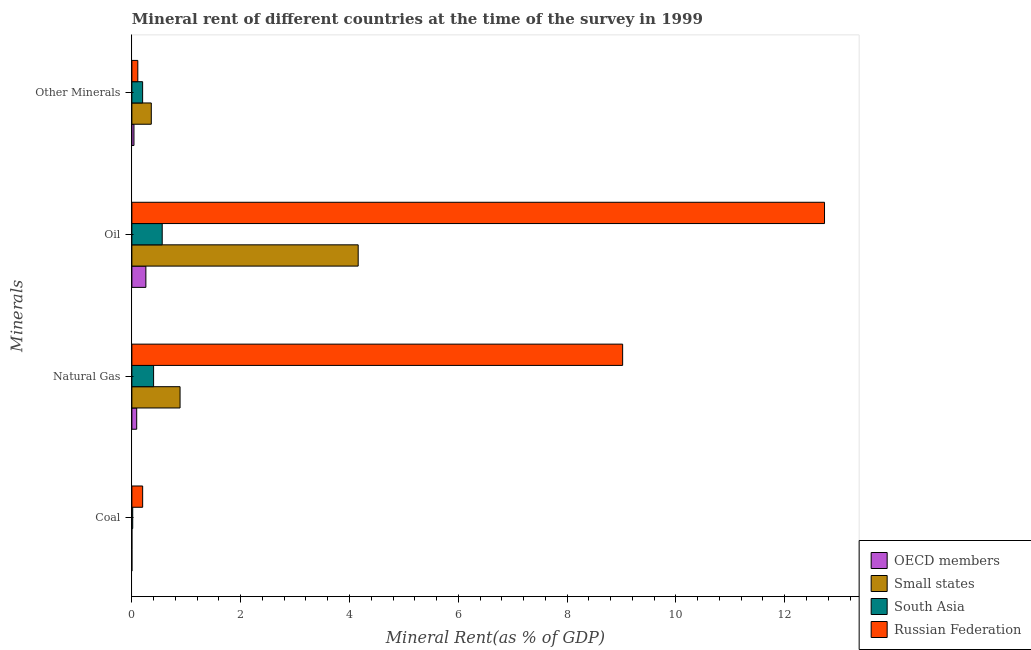How many different coloured bars are there?
Offer a very short reply. 4. How many groups of bars are there?
Offer a very short reply. 4. Are the number of bars per tick equal to the number of legend labels?
Your answer should be very brief. Yes. What is the label of the 4th group of bars from the top?
Offer a very short reply. Coal. What is the oil rent in Small states?
Provide a succinct answer. 4.16. Across all countries, what is the maximum  rent of other minerals?
Offer a very short reply. 0.36. Across all countries, what is the minimum  rent of other minerals?
Your answer should be very brief. 0.04. In which country was the  rent of other minerals maximum?
Ensure brevity in your answer.  Small states. What is the total natural gas rent in the graph?
Keep it short and to the point. 10.39. What is the difference between the natural gas rent in Russian Federation and that in OECD members?
Your response must be concise. 8.93. What is the difference between the oil rent in South Asia and the natural gas rent in OECD members?
Provide a short and direct response. 0.47. What is the average natural gas rent per country?
Offer a terse response. 2.6. What is the difference between the  rent of other minerals and coal rent in Small states?
Keep it short and to the point. 0.36. What is the ratio of the oil rent in Russian Federation to that in South Asia?
Your answer should be very brief. 22.82. Is the natural gas rent in Small states less than that in Russian Federation?
Keep it short and to the point. Yes. What is the difference between the highest and the second highest natural gas rent?
Give a very brief answer. 8.13. What is the difference between the highest and the lowest  rent of other minerals?
Ensure brevity in your answer.  0.32. In how many countries, is the coal rent greater than the average coal rent taken over all countries?
Make the answer very short. 1. What does the 2nd bar from the bottom in Oil represents?
Provide a short and direct response. Small states. Is it the case that in every country, the sum of the coal rent and natural gas rent is greater than the oil rent?
Keep it short and to the point. No. Are all the bars in the graph horizontal?
Your answer should be very brief. Yes. Are the values on the major ticks of X-axis written in scientific E-notation?
Give a very brief answer. No. Where does the legend appear in the graph?
Your answer should be compact. Bottom right. What is the title of the graph?
Your answer should be very brief. Mineral rent of different countries at the time of the survey in 1999. Does "Palau" appear as one of the legend labels in the graph?
Offer a terse response. No. What is the label or title of the X-axis?
Ensure brevity in your answer.  Mineral Rent(as % of GDP). What is the label or title of the Y-axis?
Ensure brevity in your answer.  Minerals. What is the Mineral Rent(as % of GDP) of OECD members in Coal?
Your response must be concise. 7.35477210860239e-5. What is the Mineral Rent(as % of GDP) in Small states in Coal?
Give a very brief answer. 3.53055328740538e-5. What is the Mineral Rent(as % of GDP) of South Asia in Coal?
Provide a succinct answer. 0.02. What is the Mineral Rent(as % of GDP) in Russian Federation in Coal?
Ensure brevity in your answer.  0.2. What is the Mineral Rent(as % of GDP) in OECD members in Natural Gas?
Offer a terse response. 0.09. What is the Mineral Rent(as % of GDP) in Small states in Natural Gas?
Your response must be concise. 0.89. What is the Mineral Rent(as % of GDP) of South Asia in Natural Gas?
Offer a terse response. 0.4. What is the Mineral Rent(as % of GDP) of Russian Federation in Natural Gas?
Your response must be concise. 9.02. What is the Mineral Rent(as % of GDP) in OECD members in Oil?
Keep it short and to the point. 0.26. What is the Mineral Rent(as % of GDP) of Small states in Oil?
Make the answer very short. 4.16. What is the Mineral Rent(as % of GDP) of South Asia in Oil?
Keep it short and to the point. 0.56. What is the Mineral Rent(as % of GDP) of Russian Federation in Oil?
Your answer should be very brief. 12.73. What is the Mineral Rent(as % of GDP) of OECD members in Other Minerals?
Make the answer very short. 0.04. What is the Mineral Rent(as % of GDP) of Small states in Other Minerals?
Give a very brief answer. 0.36. What is the Mineral Rent(as % of GDP) in South Asia in Other Minerals?
Your response must be concise. 0.2. What is the Mineral Rent(as % of GDP) in Russian Federation in Other Minerals?
Provide a short and direct response. 0.11. Across all Minerals, what is the maximum Mineral Rent(as % of GDP) in OECD members?
Provide a succinct answer. 0.26. Across all Minerals, what is the maximum Mineral Rent(as % of GDP) in Small states?
Ensure brevity in your answer.  4.16. Across all Minerals, what is the maximum Mineral Rent(as % of GDP) of South Asia?
Offer a terse response. 0.56. Across all Minerals, what is the maximum Mineral Rent(as % of GDP) of Russian Federation?
Your answer should be compact. 12.73. Across all Minerals, what is the minimum Mineral Rent(as % of GDP) of OECD members?
Make the answer very short. 7.35477210860239e-5. Across all Minerals, what is the minimum Mineral Rent(as % of GDP) of Small states?
Offer a terse response. 3.53055328740538e-5. Across all Minerals, what is the minimum Mineral Rent(as % of GDP) in South Asia?
Offer a very short reply. 0.02. Across all Minerals, what is the minimum Mineral Rent(as % of GDP) in Russian Federation?
Provide a succinct answer. 0.11. What is the total Mineral Rent(as % of GDP) of OECD members in the graph?
Give a very brief answer. 0.38. What is the total Mineral Rent(as % of GDP) in Small states in the graph?
Offer a very short reply. 5.4. What is the total Mineral Rent(as % of GDP) in South Asia in the graph?
Give a very brief answer. 1.17. What is the total Mineral Rent(as % of GDP) in Russian Federation in the graph?
Provide a short and direct response. 22.06. What is the difference between the Mineral Rent(as % of GDP) in OECD members in Coal and that in Natural Gas?
Make the answer very short. -0.09. What is the difference between the Mineral Rent(as % of GDP) in Small states in Coal and that in Natural Gas?
Offer a very short reply. -0.89. What is the difference between the Mineral Rent(as % of GDP) of South Asia in Coal and that in Natural Gas?
Your answer should be compact. -0.38. What is the difference between the Mineral Rent(as % of GDP) of Russian Federation in Coal and that in Natural Gas?
Ensure brevity in your answer.  -8.82. What is the difference between the Mineral Rent(as % of GDP) of OECD members in Coal and that in Oil?
Provide a short and direct response. -0.26. What is the difference between the Mineral Rent(as % of GDP) of Small states in Coal and that in Oil?
Make the answer very short. -4.16. What is the difference between the Mineral Rent(as % of GDP) in South Asia in Coal and that in Oil?
Ensure brevity in your answer.  -0.54. What is the difference between the Mineral Rent(as % of GDP) in Russian Federation in Coal and that in Oil?
Ensure brevity in your answer.  -12.53. What is the difference between the Mineral Rent(as % of GDP) in OECD members in Coal and that in Other Minerals?
Ensure brevity in your answer.  -0.04. What is the difference between the Mineral Rent(as % of GDP) in Small states in Coal and that in Other Minerals?
Provide a succinct answer. -0.36. What is the difference between the Mineral Rent(as % of GDP) in South Asia in Coal and that in Other Minerals?
Your answer should be compact. -0.18. What is the difference between the Mineral Rent(as % of GDP) of Russian Federation in Coal and that in Other Minerals?
Provide a succinct answer. 0.09. What is the difference between the Mineral Rent(as % of GDP) in OECD members in Natural Gas and that in Oil?
Offer a terse response. -0.17. What is the difference between the Mineral Rent(as % of GDP) in Small states in Natural Gas and that in Oil?
Make the answer very short. -3.27. What is the difference between the Mineral Rent(as % of GDP) in South Asia in Natural Gas and that in Oil?
Offer a terse response. -0.16. What is the difference between the Mineral Rent(as % of GDP) in Russian Federation in Natural Gas and that in Oil?
Your response must be concise. -3.71. What is the difference between the Mineral Rent(as % of GDP) of OECD members in Natural Gas and that in Other Minerals?
Make the answer very short. 0.05. What is the difference between the Mineral Rent(as % of GDP) in Small states in Natural Gas and that in Other Minerals?
Offer a very short reply. 0.53. What is the difference between the Mineral Rent(as % of GDP) of South Asia in Natural Gas and that in Other Minerals?
Provide a short and direct response. 0.2. What is the difference between the Mineral Rent(as % of GDP) of Russian Federation in Natural Gas and that in Other Minerals?
Keep it short and to the point. 8.91. What is the difference between the Mineral Rent(as % of GDP) of OECD members in Oil and that in Other Minerals?
Offer a very short reply. 0.22. What is the difference between the Mineral Rent(as % of GDP) of Small states in Oil and that in Other Minerals?
Your response must be concise. 3.8. What is the difference between the Mineral Rent(as % of GDP) in South Asia in Oil and that in Other Minerals?
Provide a short and direct response. 0.36. What is the difference between the Mineral Rent(as % of GDP) in Russian Federation in Oil and that in Other Minerals?
Offer a terse response. 12.62. What is the difference between the Mineral Rent(as % of GDP) in OECD members in Coal and the Mineral Rent(as % of GDP) in Small states in Natural Gas?
Offer a terse response. -0.89. What is the difference between the Mineral Rent(as % of GDP) of OECD members in Coal and the Mineral Rent(as % of GDP) of South Asia in Natural Gas?
Your response must be concise. -0.4. What is the difference between the Mineral Rent(as % of GDP) of OECD members in Coal and the Mineral Rent(as % of GDP) of Russian Federation in Natural Gas?
Offer a very short reply. -9.02. What is the difference between the Mineral Rent(as % of GDP) of Small states in Coal and the Mineral Rent(as % of GDP) of South Asia in Natural Gas?
Make the answer very short. -0.4. What is the difference between the Mineral Rent(as % of GDP) of Small states in Coal and the Mineral Rent(as % of GDP) of Russian Federation in Natural Gas?
Give a very brief answer. -9.02. What is the difference between the Mineral Rent(as % of GDP) in South Asia in Coal and the Mineral Rent(as % of GDP) in Russian Federation in Natural Gas?
Offer a terse response. -9. What is the difference between the Mineral Rent(as % of GDP) of OECD members in Coal and the Mineral Rent(as % of GDP) of Small states in Oil?
Give a very brief answer. -4.16. What is the difference between the Mineral Rent(as % of GDP) in OECD members in Coal and the Mineral Rent(as % of GDP) in South Asia in Oil?
Keep it short and to the point. -0.56. What is the difference between the Mineral Rent(as % of GDP) in OECD members in Coal and the Mineral Rent(as % of GDP) in Russian Federation in Oil?
Make the answer very short. -12.73. What is the difference between the Mineral Rent(as % of GDP) of Small states in Coal and the Mineral Rent(as % of GDP) of South Asia in Oil?
Make the answer very short. -0.56. What is the difference between the Mineral Rent(as % of GDP) of Small states in Coal and the Mineral Rent(as % of GDP) of Russian Federation in Oil?
Provide a short and direct response. -12.73. What is the difference between the Mineral Rent(as % of GDP) in South Asia in Coal and the Mineral Rent(as % of GDP) in Russian Federation in Oil?
Offer a very short reply. -12.72. What is the difference between the Mineral Rent(as % of GDP) in OECD members in Coal and the Mineral Rent(as % of GDP) in Small states in Other Minerals?
Give a very brief answer. -0.36. What is the difference between the Mineral Rent(as % of GDP) in OECD members in Coal and the Mineral Rent(as % of GDP) in South Asia in Other Minerals?
Your response must be concise. -0.2. What is the difference between the Mineral Rent(as % of GDP) in OECD members in Coal and the Mineral Rent(as % of GDP) in Russian Federation in Other Minerals?
Offer a very short reply. -0.11. What is the difference between the Mineral Rent(as % of GDP) in Small states in Coal and the Mineral Rent(as % of GDP) in South Asia in Other Minerals?
Ensure brevity in your answer.  -0.2. What is the difference between the Mineral Rent(as % of GDP) in Small states in Coal and the Mineral Rent(as % of GDP) in Russian Federation in Other Minerals?
Your answer should be very brief. -0.11. What is the difference between the Mineral Rent(as % of GDP) of South Asia in Coal and the Mineral Rent(as % of GDP) of Russian Federation in Other Minerals?
Your answer should be very brief. -0.09. What is the difference between the Mineral Rent(as % of GDP) of OECD members in Natural Gas and the Mineral Rent(as % of GDP) of Small states in Oil?
Provide a succinct answer. -4.07. What is the difference between the Mineral Rent(as % of GDP) of OECD members in Natural Gas and the Mineral Rent(as % of GDP) of South Asia in Oil?
Keep it short and to the point. -0.47. What is the difference between the Mineral Rent(as % of GDP) in OECD members in Natural Gas and the Mineral Rent(as % of GDP) in Russian Federation in Oil?
Ensure brevity in your answer.  -12.64. What is the difference between the Mineral Rent(as % of GDP) of Small states in Natural Gas and the Mineral Rent(as % of GDP) of South Asia in Oil?
Your answer should be compact. 0.33. What is the difference between the Mineral Rent(as % of GDP) of Small states in Natural Gas and the Mineral Rent(as % of GDP) of Russian Federation in Oil?
Give a very brief answer. -11.85. What is the difference between the Mineral Rent(as % of GDP) in South Asia in Natural Gas and the Mineral Rent(as % of GDP) in Russian Federation in Oil?
Your answer should be compact. -12.33. What is the difference between the Mineral Rent(as % of GDP) in OECD members in Natural Gas and the Mineral Rent(as % of GDP) in Small states in Other Minerals?
Offer a very short reply. -0.27. What is the difference between the Mineral Rent(as % of GDP) of OECD members in Natural Gas and the Mineral Rent(as % of GDP) of South Asia in Other Minerals?
Your response must be concise. -0.11. What is the difference between the Mineral Rent(as % of GDP) in OECD members in Natural Gas and the Mineral Rent(as % of GDP) in Russian Federation in Other Minerals?
Offer a very short reply. -0.02. What is the difference between the Mineral Rent(as % of GDP) in Small states in Natural Gas and the Mineral Rent(as % of GDP) in South Asia in Other Minerals?
Ensure brevity in your answer.  0.69. What is the difference between the Mineral Rent(as % of GDP) of Small states in Natural Gas and the Mineral Rent(as % of GDP) of Russian Federation in Other Minerals?
Your answer should be compact. 0.78. What is the difference between the Mineral Rent(as % of GDP) of South Asia in Natural Gas and the Mineral Rent(as % of GDP) of Russian Federation in Other Minerals?
Your answer should be very brief. 0.29. What is the difference between the Mineral Rent(as % of GDP) of OECD members in Oil and the Mineral Rent(as % of GDP) of Small states in Other Minerals?
Make the answer very short. -0.1. What is the difference between the Mineral Rent(as % of GDP) of OECD members in Oil and the Mineral Rent(as % of GDP) of South Asia in Other Minerals?
Your answer should be compact. 0.06. What is the difference between the Mineral Rent(as % of GDP) in OECD members in Oil and the Mineral Rent(as % of GDP) in Russian Federation in Other Minerals?
Your answer should be compact. 0.15. What is the difference between the Mineral Rent(as % of GDP) in Small states in Oil and the Mineral Rent(as % of GDP) in South Asia in Other Minerals?
Offer a very short reply. 3.96. What is the difference between the Mineral Rent(as % of GDP) in Small states in Oil and the Mineral Rent(as % of GDP) in Russian Federation in Other Minerals?
Make the answer very short. 4.05. What is the difference between the Mineral Rent(as % of GDP) in South Asia in Oil and the Mineral Rent(as % of GDP) in Russian Federation in Other Minerals?
Offer a terse response. 0.45. What is the average Mineral Rent(as % of GDP) in OECD members per Minerals?
Provide a short and direct response. 0.1. What is the average Mineral Rent(as % of GDP) in Small states per Minerals?
Ensure brevity in your answer.  1.35. What is the average Mineral Rent(as % of GDP) in South Asia per Minerals?
Ensure brevity in your answer.  0.29. What is the average Mineral Rent(as % of GDP) in Russian Federation per Minerals?
Ensure brevity in your answer.  5.51. What is the difference between the Mineral Rent(as % of GDP) in OECD members and Mineral Rent(as % of GDP) in South Asia in Coal?
Offer a very short reply. -0.02. What is the difference between the Mineral Rent(as % of GDP) of OECD members and Mineral Rent(as % of GDP) of Russian Federation in Coal?
Give a very brief answer. -0.2. What is the difference between the Mineral Rent(as % of GDP) of Small states and Mineral Rent(as % of GDP) of South Asia in Coal?
Your answer should be compact. -0.02. What is the difference between the Mineral Rent(as % of GDP) of Small states and Mineral Rent(as % of GDP) of Russian Federation in Coal?
Offer a very short reply. -0.2. What is the difference between the Mineral Rent(as % of GDP) of South Asia and Mineral Rent(as % of GDP) of Russian Federation in Coal?
Your answer should be very brief. -0.18. What is the difference between the Mineral Rent(as % of GDP) in OECD members and Mineral Rent(as % of GDP) in Small states in Natural Gas?
Ensure brevity in your answer.  -0.8. What is the difference between the Mineral Rent(as % of GDP) of OECD members and Mineral Rent(as % of GDP) of South Asia in Natural Gas?
Provide a succinct answer. -0.31. What is the difference between the Mineral Rent(as % of GDP) in OECD members and Mineral Rent(as % of GDP) in Russian Federation in Natural Gas?
Offer a very short reply. -8.93. What is the difference between the Mineral Rent(as % of GDP) in Small states and Mineral Rent(as % of GDP) in South Asia in Natural Gas?
Your answer should be compact. 0.49. What is the difference between the Mineral Rent(as % of GDP) of Small states and Mineral Rent(as % of GDP) of Russian Federation in Natural Gas?
Offer a terse response. -8.13. What is the difference between the Mineral Rent(as % of GDP) in South Asia and Mineral Rent(as % of GDP) in Russian Federation in Natural Gas?
Offer a very short reply. -8.62. What is the difference between the Mineral Rent(as % of GDP) in OECD members and Mineral Rent(as % of GDP) in Small states in Oil?
Make the answer very short. -3.9. What is the difference between the Mineral Rent(as % of GDP) of OECD members and Mineral Rent(as % of GDP) of South Asia in Oil?
Ensure brevity in your answer.  -0.3. What is the difference between the Mineral Rent(as % of GDP) of OECD members and Mineral Rent(as % of GDP) of Russian Federation in Oil?
Make the answer very short. -12.47. What is the difference between the Mineral Rent(as % of GDP) of Small states and Mineral Rent(as % of GDP) of South Asia in Oil?
Your answer should be compact. 3.6. What is the difference between the Mineral Rent(as % of GDP) of Small states and Mineral Rent(as % of GDP) of Russian Federation in Oil?
Provide a succinct answer. -8.57. What is the difference between the Mineral Rent(as % of GDP) in South Asia and Mineral Rent(as % of GDP) in Russian Federation in Oil?
Make the answer very short. -12.17. What is the difference between the Mineral Rent(as % of GDP) in OECD members and Mineral Rent(as % of GDP) in Small states in Other Minerals?
Your answer should be compact. -0.32. What is the difference between the Mineral Rent(as % of GDP) in OECD members and Mineral Rent(as % of GDP) in South Asia in Other Minerals?
Your response must be concise. -0.16. What is the difference between the Mineral Rent(as % of GDP) of OECD members and Mineral Rent(as % of GDP) of Russian Federation in Other Minerals?
Give a very brief answer. -0.07. What is the difference between the Mineral Rent(as % of GDP) in Small states and Mineral Rent(as % of GDP) in South Asia in Other Minerals?
Keep it short and to the point. 0.16. What is the difference between the Mineral Rent(as % of GDP) of Small states and Mineral Rent(as % of GDP) of Russian Federation in Other Minerals?
Ensure brevity in your answer.  0.25. What is the difference between the Mineral Rent(as % of GDP) in South Asia and Mineral Rent(as % of GDP) in Russian Federation in Other Minerals?
Your answer should be compact. 0.09. What is the ratio of the Mineral Rent(as % of GDP) in OECD members in Coal to that in Natural Gas?
Keep it short and to the point. 0. What is the ratio of the Mineral Rent(as % of GDP) in South Asia in Coal to that in Natural Gas?
Give a very brief answer. 0.04. What is the ratio of the Mineral Rent(as % of GDP) of Russian Federation in Coal to that in Natural Gas?
Your answer should be compact. 0.02. What is the ratio of the Mineral Rent(as % of GDP) of South Asia in Coal to that in Oil?
Give a very brief answer. 0.03. What is the ratio of the Mineral Rent(as % of GDP) in Russian Federation in Coal to that in Oil?
Offer a terse response. 0.02. What is the ratio of the Mineral Rent(as % of GDP) in OECD members in Coal to that in Other Minerals?
Your answer should be very brief. 0. What is the ratio of the Mineral Rent(as % of GDP) of South Asia in Coal to that in Other Minerals?
Your answer should be compact. 0.08. What is the ratio of the Mineral Rent(as % of GDP) in Russian Federation in Coal to that in Other Minerals?
Give a very brief answer. 1.81. What is the ratio of the Mineral Rent(as % of GDP) of OECD members in Natural Gas to that in Oil?
Ensure brevity in your answer.  0.35. What is the ratio of the Mineral Rent(as % of GDP) in Small states in Natural Gas to that in Oil?
Make the answer very short. 0.21. What is the ratio of the Mineral Rent(as % of GDP) of South Asia in Natural Gas to that in Oil?
Offer a very short reply. 0.72. What is the ratio of the Mineral Rent(as % of GDP) of Russian Federation in Natural Gas to that in Oil?
Ensure brevity in your answer.  0.71. What is the ratio of the Mineral Rent(as % of GDP) in OECD members in Natural Gas to that in Other Minerals?
Provide a short and direct response. 2.32. What is the ratio of the Mineral Rent(as % of GDP) of Small states in Natural Gas to that in Other Minerals?
Your answer should be compact. 2.48. What is the ratio of the Mineral Rent(as % of GDP) of South Asia in Natural Gas to that in Other Minerals?
Your answer should be compact. 2.02. What is the ratio of the Mineral Rent(as % of GDP) in Russian Federation in Natural Gas to that in Other Minerals?
Your response must be concise. 82.56. What is the ratio of the Mineral Rent(as % of GDP) in OECD members in Oil to that in Other Minerals?
Your answer should be compact. 6.71. What is the ratio of the Mineral Rent(as % of GDP) of Small states in Oil to that in Other Minerals?
Ensure brevity in your answer.  11.65. What is the ratio of the Mineral Rent(as % of GDP) of South Asia in Oil to that in Other Minerals?
Offer a very short reply. 2.82. What is the ratio of the Mineral Rent(as % of GDP) in Russian Federation in Oil to that in Other Minerals?
Ensure brevity in your answer.  116.52. What is the difference between the highest and the second highest Mineral Rent(as % of GDP) of OECD members?
Keep it short and to the point. 0.17. What is the difference between the highest and the second highest Mineral Rent(as % of GDP) of Small states?
Your response must be concise. 3.27. What is the difference between the highest and the second highest Mineral Rent(as % of GDP) of South Asia?
Ensure brevity in your answer.  0.16. What is the difference between the highest and the second highest Mineral Rent(as % of GDP) in Russian Federation?
Make the answer very short. 3.71. What is the difference between the highest and the lowest Mineral Rent(as % of GDP) of OECD members?
Your response must be concise. 0.26. What is the difference between the highest and the lowest Mineral Rent(as % of GDP) of Small states?
Offer a very short reply. 4.16. What is the difference between the highest and the lowest Mineral Rent(as % of GDP) of South Asia?
Make the answer very short. 0.54. What is the difference between the highest and the lowest Mineral Rent(as % of GDP) in Russian Federation?
Your response must be concise. 12.62. 